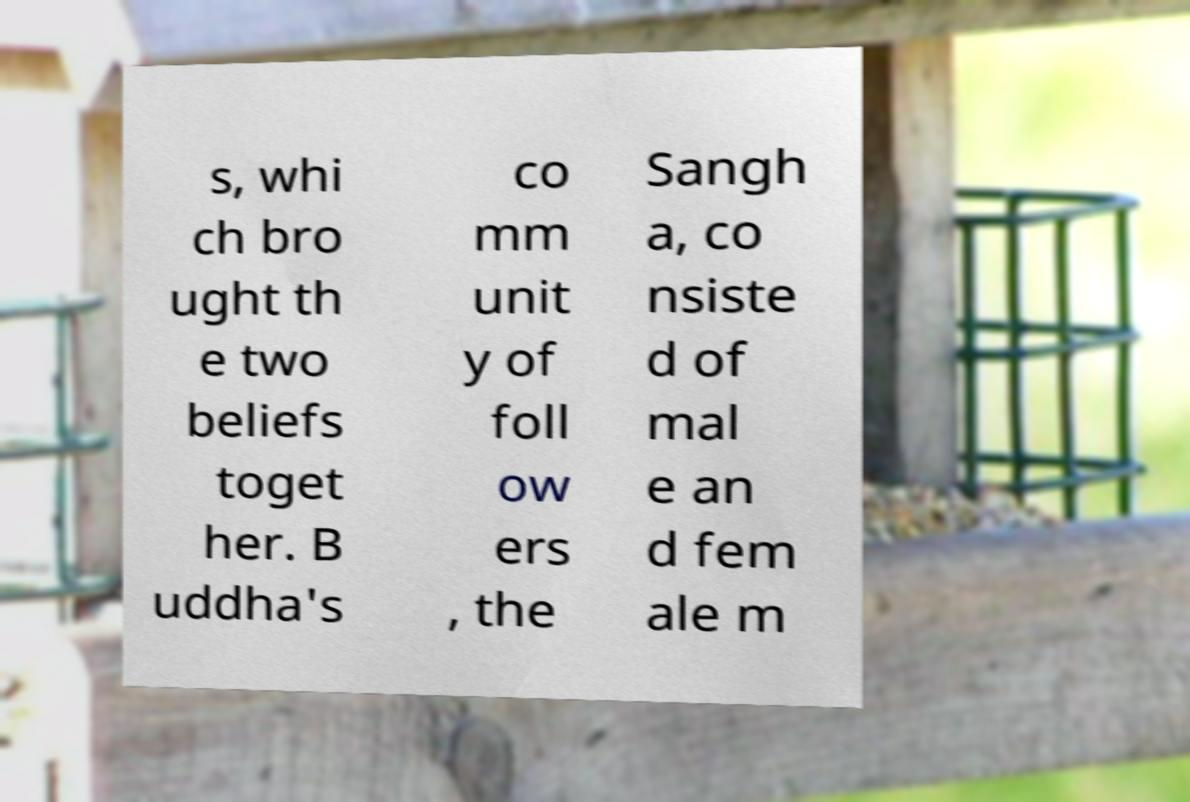What messages or text are displayed in this image? I need them in a readable, typed format. s, whi ch bro ught th e two beliefs toget her. B uddha's co mm unit y of foll ow ers , the Sangh a, co nsiste d of mal e an d fem ale m 